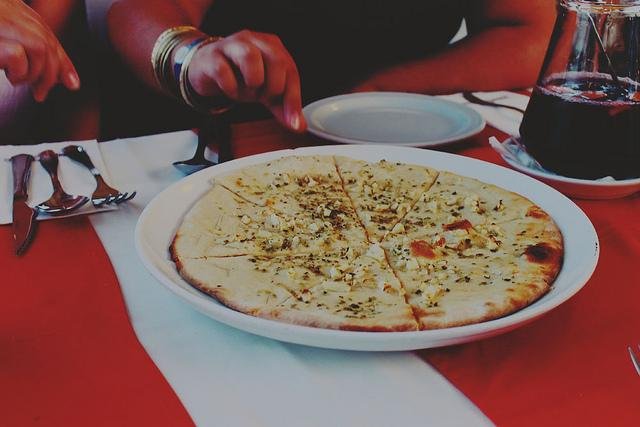What can one of the shiny silver things do? cut 